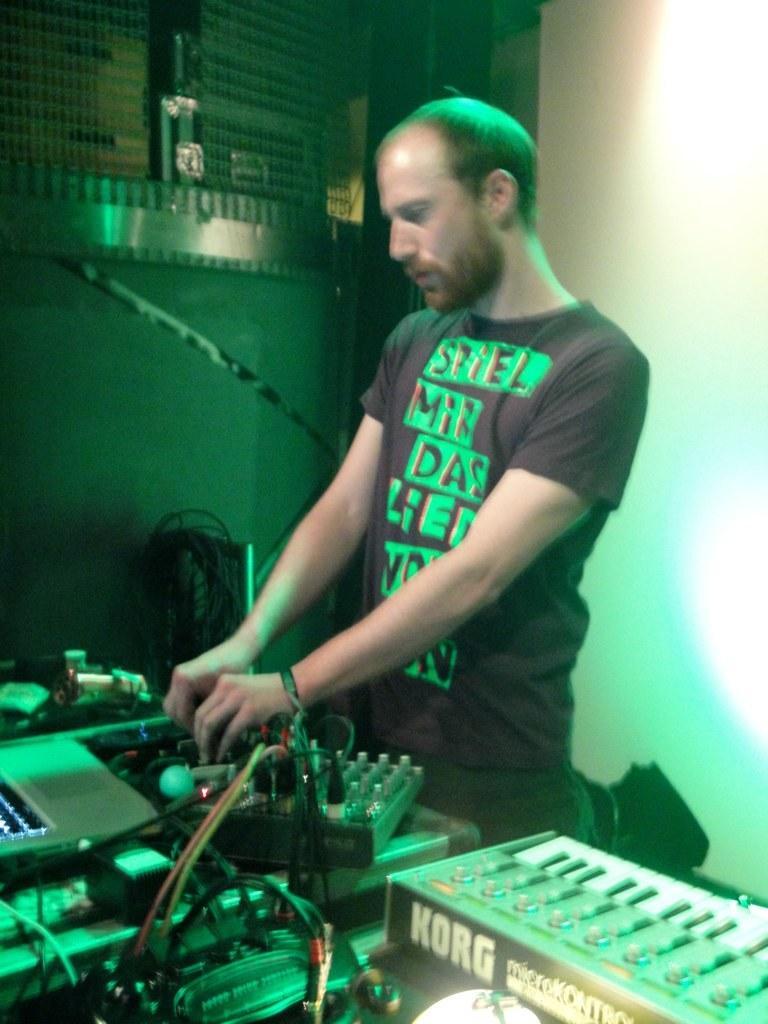Could you give a brief overview of what you see in this image? In this image, we can see a person is standing. At the bottom, we can see some machines, wires, piano. Background there is a wall. Here we can see a grill. 